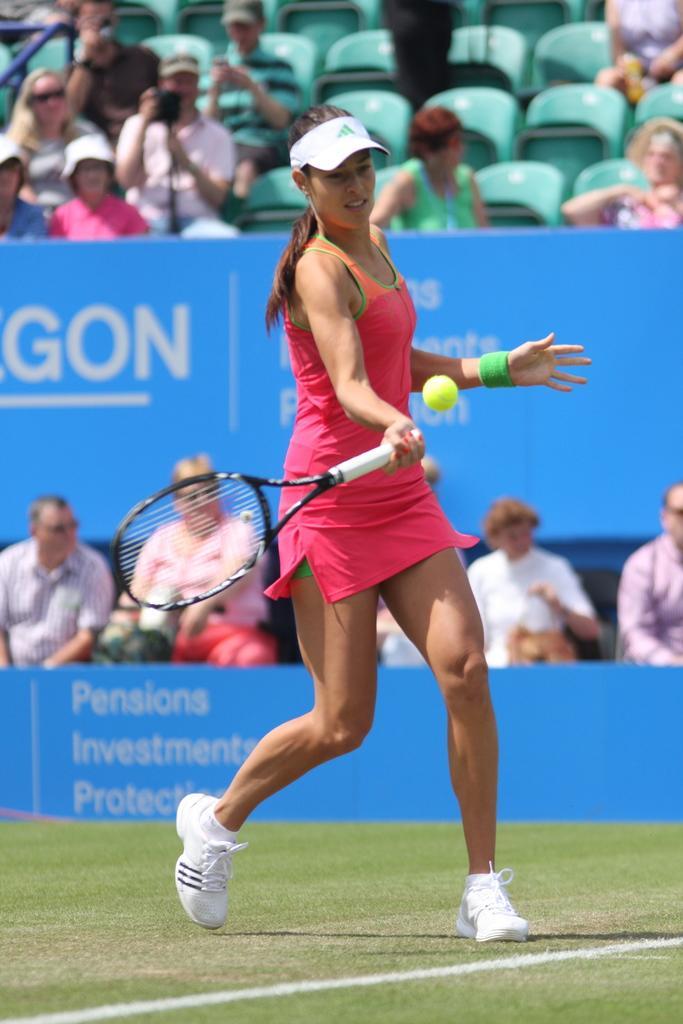In one or two sentences, can you explain what this image depicts? This picture is taken in the stadium, In the middle there is a woman she is standing and she is holding a bat which is in white color she is hitting a ball which is in yellow color, In the background there are some chairs which are in green color, There are some people sitting on the chairs, There is a blue color poster. 